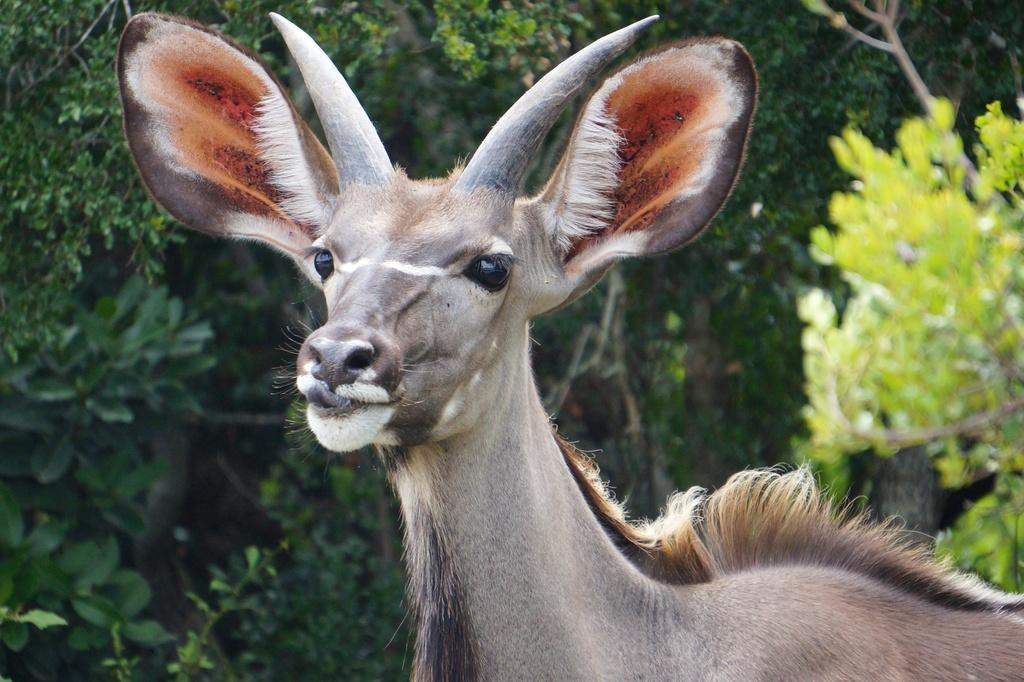What is the main subject in the center of the image? There is an animal in the center of the image. What can be seen in the background of the image? There are trees in the background of the image. What type of sack can be seen hanging from the tree in the image? There is no sack present in the image; it only features an animal and trees in the background. 